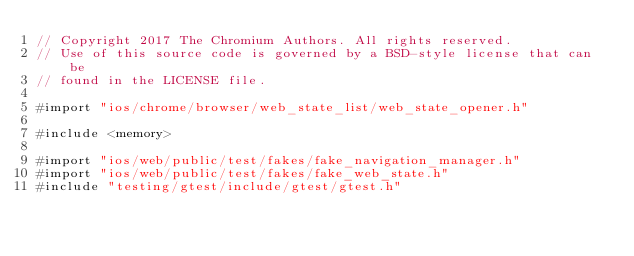<code> <loc_0><loc_0><loc_500><loc_500><_ObjectiveC_>// Copyright 2017 The Chromium Authors. All rights reserved.
// Use of this source code is governed by a BSD-style license that can be
// found in the LICENSE file.

#import "ios/chrome/browser/web_state_list/web_state_opener.h"

#include <memory>

#import "ios/web/public/test/fakes/fake_navigation_manager.h"
#import "ios/web/public/test/fakes/fake_web_state.h"
#include "testing/gtest/include/gtest/gtest.h"</code> 